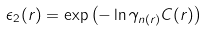<formula> <loc_0><loc_0><loc_500><loc_500>\epsilon _ { 2 } ( r ) = \exp \left ( - \ln \gamma _ { n ( r ) } C ( r ) \right )</formula> 